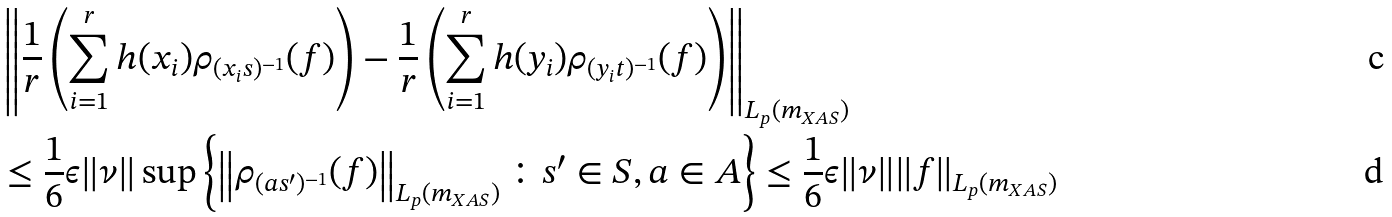<formula> <loc_0><loc_0><loc_500><loc_500>& \left \| \frac { 1 } { r } \left ( \sum _ { i = 1 } ^ { r } { h ( x _ { i } ) \rho _ { ( x _ { i } s ) ^ { - 1 } } ( f ) } \right ) - \frac { 1 } { r } \left ( \sum _ { i = 1 } ^ { r } { h ( y _ { i } ) \rho _ { ( y _ { i } t ) ^ { - 1 } } ( f ) } \right ) \right \| _ { L _ { p } ( m _ { X A S } ) } \\ & \leq \frac { 1 } { 6 } \epsilon \| \nu \| \sup { \left \{ \left \| \rho _ { ( a s ^ { \prime } ) ^ { - 1 } } ( f ) \right \| _ { L _ { p } ( m _ { X A S } ) } \colon s ^ { \prime } \in S , a \in A \right \} } \leq \frac { 1 } { 6 } \epsilon \| \nu \| \| f \| _ { L _ { p } ( m _ { X A S } ) }</formula> 